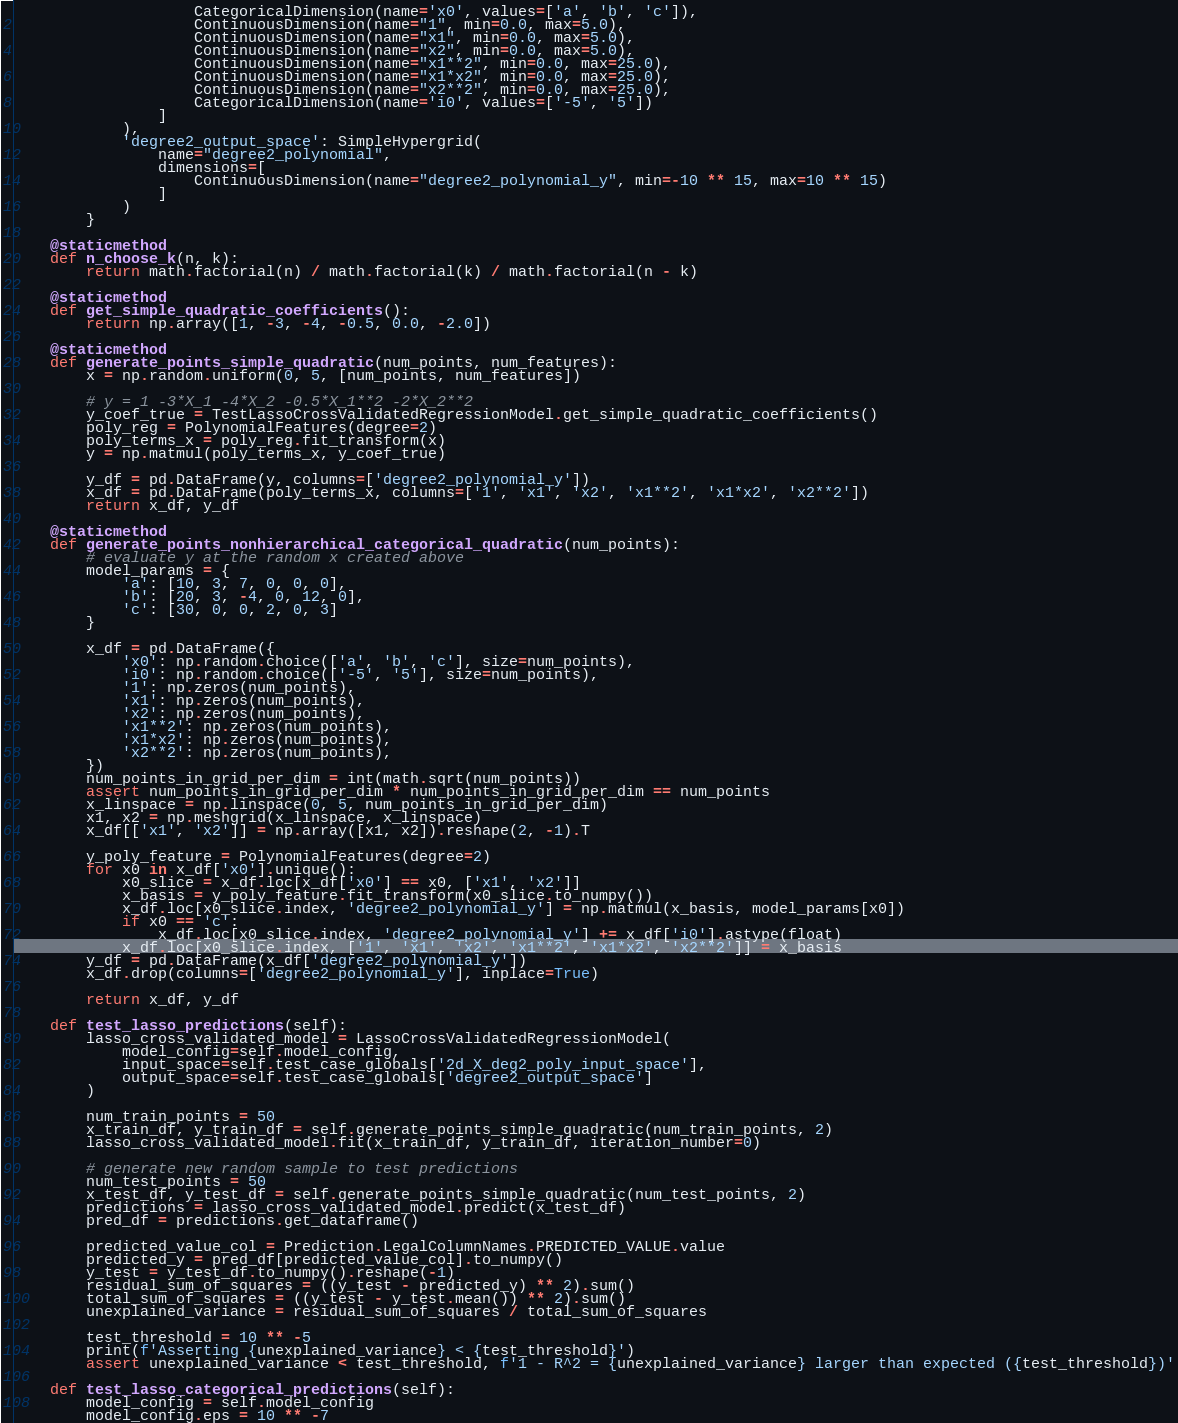<code> <loc_0><loc_0><loc_500><loc_500><_Python_>                    CategoricalDimension(name='x0', values=['a', 'b', 'c']),
                    ContinuousDimension(name="1", min=0.0, max=5.0),
                    ContinuousDimension(name="x1", min=0.0, max=5.0),
                    ContinuousDimension(name="x2", min=0.0, max=5.0),
                    ContinuousDimension(name="x1**2", min=0.0, max=25.0),
                    ContinuousDimension(name="x1*x2", min=0.0, max=25.0),
                    ContinuousDimension(name="x2**2", min=0.0, max=25.0),
                    CategoricalDimension(name='i0', values=['-5', '5'])
                ]
            ),
            'degree2_output_space': SimpleHypergrid(
                name="degree2_polynomial",
                dimensions=[
                    ContinuousDimension(name="degree2_polynomial_y", min=-10 ** 15, max=10 ** 15)
                ]
            )
        }

    @staticmethod
    def n_choose_k(n, k):
        return math.factorial(n) / math.factorial(k) / math.factorial(n - k)

    @staticmethod
    def get_simple_quadratic_coefficients():
        return np.array([1, -3, -4, -0.5, 0.0, -2.0])

    @staticmethod
    def generate_points_simple_quadratic(num_points, num_features):
        x = np.random.uniform(0, 5, [num_points, num_features])

        # y = 1 -3*X_1 -4*X_2 -0.5*X_1**2 -2*X_2**2
        y_coef_true = TestLassoCrossValidatedRegressionModel.get_simple_quadratic_coefficients()
        poly_reg = PolynomialFeatures(degree=2)
        poly_terms_x = poly_reg.fit_transform(x)
        y = np.matmul(poly_terms_x, y_coef_true)

        y_df = pd.DataFrame(y, columns=['degree2_polynomial_y'])
        x_df = pd.DataFrame(poly_terms_x, columns=['1', 'x1', 'x2', 'x1**2', 'x1*x2', 'x2**2'])
        return x_df, y_df

    @staticmethod
    def generate_points_nonhierarchical_categorical_quadratic(num_points):
        # evaluate y at the random x created above
        model_params = {
            'a': [10, 3, 7, 0, 0, 0],
            'b': [20, 3, -4, 0, 12, 0],
            'c': [30, 0, 0, 2, 0, 3]
        }

        x_df = pd.DataFrame({
            'x0': np.random.choice(['a', 'b', 'c'], size=num_points),
            'i0': np.random.choice(['-5', '5'], size=num_points),
            '1': np.zeros(num_points),
            'x1': np.zeros(num_points),
            'x2': np.zeros(num_points),
            'x1**2': np.zeros(num_points),
            'x1*x2': np.zeros(num_points),
            'x2**2': np.zeros(num_points),
        })
        num_points_in_grid_per_dim = int(math.sqrt(num_points))
        assert num_points_in_grid_per_dim * num_points_in_grid_per_dim == num_points
        x_linspace = np.linspace(0, 5, num_points_in_grid_per_dim)
        x1, x2 = np.meshgrid(x_linspace, x_linspace)
        x_df[['x1', 'x2']] = np.array([x1, x2]).reshape(2, -1).T

        y_poly_feature = PolynomialFeatures(degree=2)
        for x0 in x_df['x0'].unique():
            x0_slice = x_df.loc[x_df['x0'] == x0, ['x1', 'x2']]
            x_basis = y_poly_feature.fit_transform(x0_slice.to_numpy())
            x_df.loc[x0_slice.index, 'degree2_polynomial_y'] = np.matmul(x_basis, model_params[x0])
            if x0 == 'c':
                x_df.loc[x0_slice.index, 'degree2_polynomial_y'] += x_df['i0'].astype(float)
            x_df.loc[x0_slice.index, ['1', 'x1', 'x2', 'x1**2', 'x1*x2', 'x2**2']] = x_basis
        y_df = pd.DataFrame(x_df['degree2_polynomial_y'])
        x_df.drop(columns=['degree2_polynomial_y'], inplace=True)

        return x_df, y_df

    def test_lasso_predictions(self):
        lasso_cross_validated_model = LassoCrossValidatedRegressionModel(
            model_config=self.model_config,
            input_space=self.test_case_globals['2d_X_deg2_poly_input_space'],
            output_space=self.test_case_globals['degree2_output_space']
        )

        num_train_points = 50
        x_train_df, y_train_df = self.generate_points_simple_quadratic(num_train_points, 2)
        lasso_cross_validated_model.fit(x_train_df, y_train_df, iteration_number=0)

        # generate new random sample to test predictions
        num_test_points = 50
        x_test_df, y_test_df = self.generate_points_simple_quadratic(num_test_points, 2)
        predictions = lasso_cross_validated_model.predict(x_test_df)
        pred_df = predictions.get_dataframe()

        predicted_value_col = Prediction.LegalColumnNames.PREDICTED_VALUE.value
        predicted_y = pred_df[predicted_value_col].to_numpy()
        y_test = y_test_df.to_numpy().reshape(-1)
        residual_sum_of_squares = ((y_test - predicted_y) ** 2).sum()
        total_sum_of_squares = ((y_test - y_test.mean()) ** 2).sum()
        unexplained_variance = residual_sum_of_squares / total_sum_of_squares

        test_threshold = 10 ** -5
        print(f'Asserting {unexplained_variance} < {test_threshold}')
        assert unexplained_variance < test_threshold, f'1 - R^2 = {unexplained_variance} larger than expected ({test_threshold})'

    def test_lasso_categorical_predictions(self):
        model_config = self.model_config
        model_config.eps = 10 ** -7</code> 